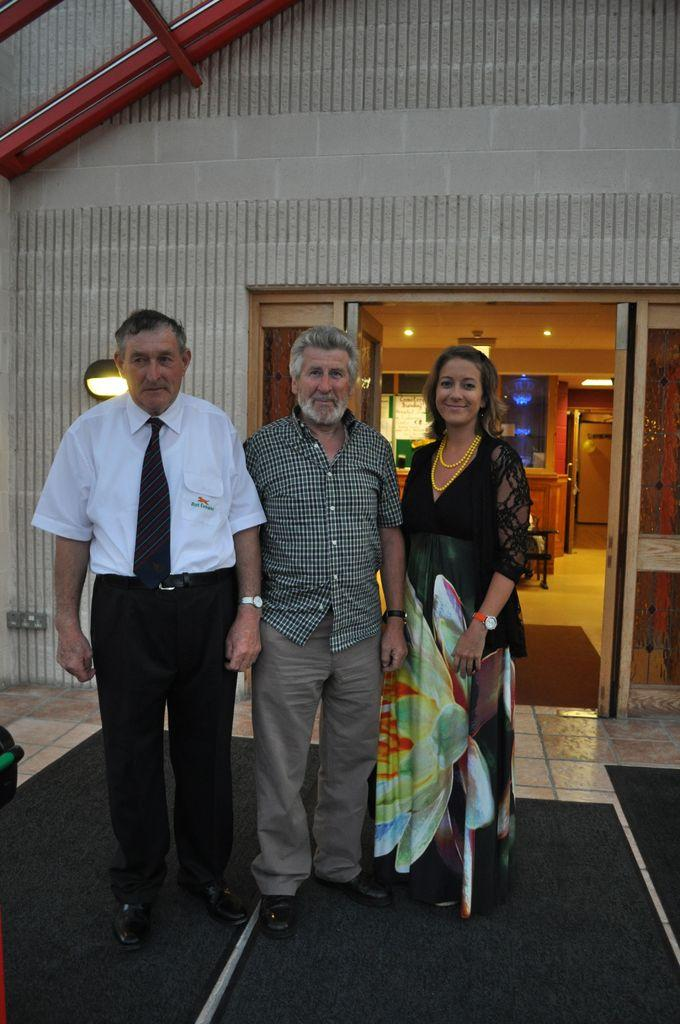How many people are in the image? There are three persons standing in the image. What is the facial expression of the persons in the image? The persons are smiling. What can be seen in the background of the image? There is a house visible in the background. What is inside the house that can be seen in the image? There is a table inside the house. What is the source of illumination inside the house? There are lights visible inside the house. Can you tell me how many cherries are on the table inside the house? There is no mention of cherries in the image, so it is not possible to determine their presence or quantity. --- Facts: 1. There is a car in the image. 2. The car is red. 3. The car has four wheels. 4. There is a road visible in the image. 5. The road is paved. Absurd Topics: parrot, sand, mountain Conversation: What is the main subject of the image? The main subject of the image is a car. What color is the car? The car is red. How many wheels does the car have? The car has four wheels. What can be seen in the background of the image? There is a road visible in the image. What is the surface of the road? The road is paved. Reasoning: Let's think step by step in order to produce the conversation. We start by identifying the main subject of the image, which is the car. Then, we describe its color and the number of wheels it has. Next, we expand the conversation to include the background and the surface of the road, which are also visible in the image. Absurd Question/Answer: Can you tell me how many parrots are sitting on the car in the image? There are no parrots visible in the image; the main subject is a red car with four wheels. Is there a mountain visible in the background of the image? No, there is no mountain present in the image. The background features a road, which is paved. 